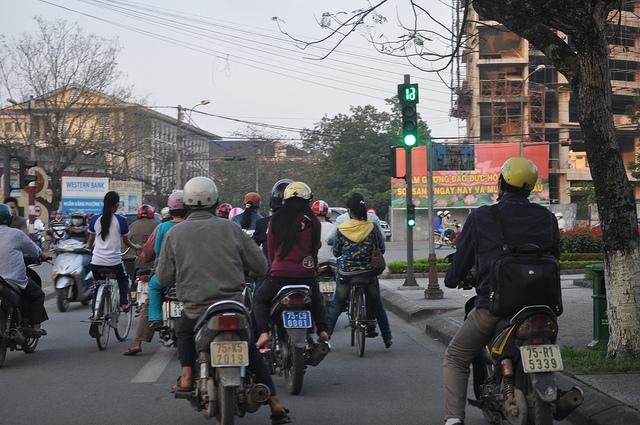What country is this street scene likely part of?

Choices:
A) laos
B) vietnam
C) cambodia
D) thailand vietnam 